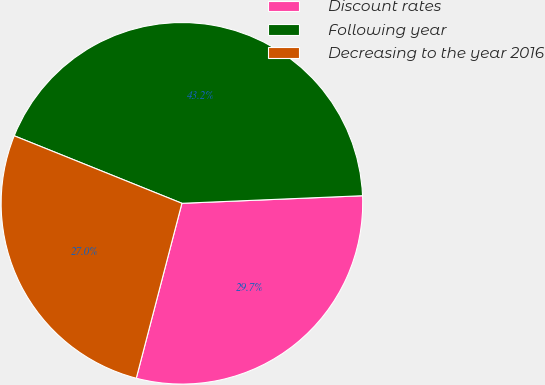Convert chart. <chart><loc_0><loc_0><loc_500><loc_500><pie_chart><fcel>Discount rates<fcel>Following year<fcel>Decreasing to the year 2016<nl><fcel>29.73%<fcel>43.24%<fcel>27.03%<nl></chart> 